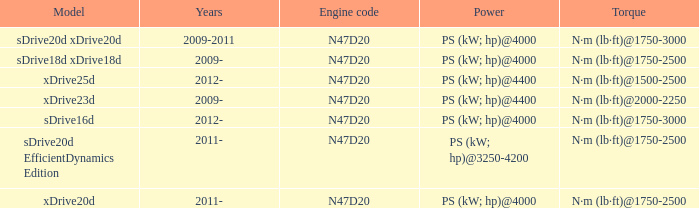What model is the n·m (lb·ft)@1500-2500 torque? Xdrive25d. 